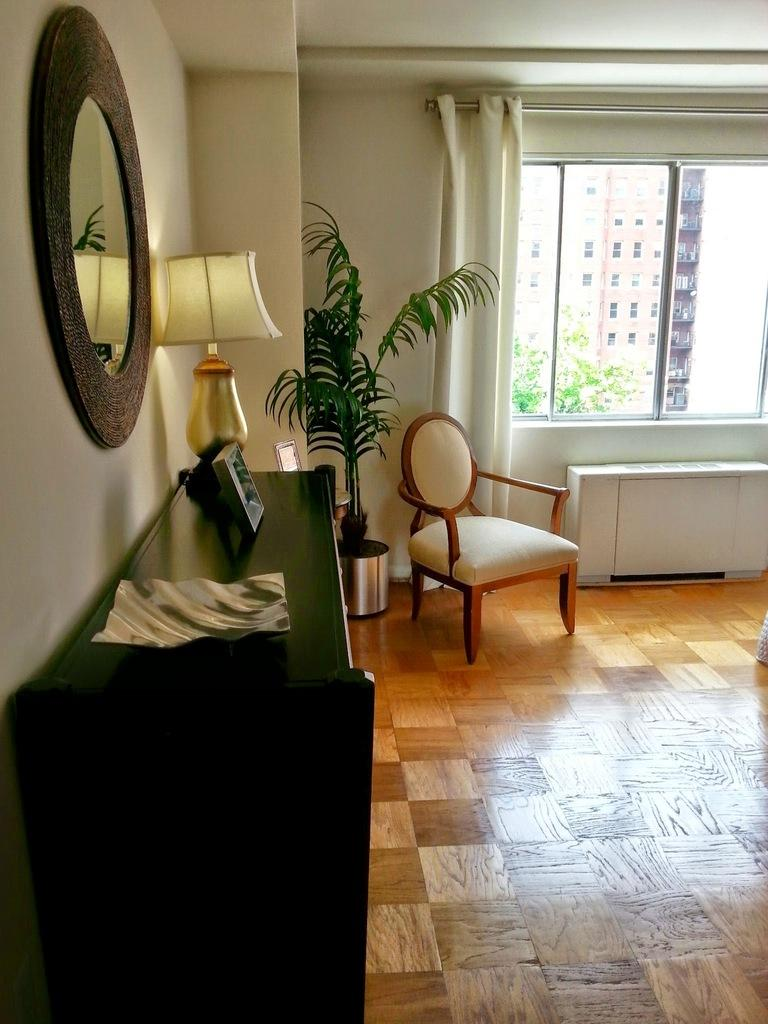What type of furniture can be seen in the image? There are tables and chairs in the image. Are there any decorative or living elements in the image? Yes, there is a plant and a framed object in the image. What type of lighting is present in the image? There is a lamp in the image. Can you describe the window and its surroundings? There is a window in the image, and it has a curtain associated with it. A building and branches are visible through the window. What is the floor like in the image? The floor is visible in the image. Can you describe the wall in the image? There is a wall in the image. What type of night can be seen in the image? There is no mention of night or any time-related information in the image. What attempt is being made by the plant in the image? The plant is not attempting anything in the image; it is simply a decorative or living element. 